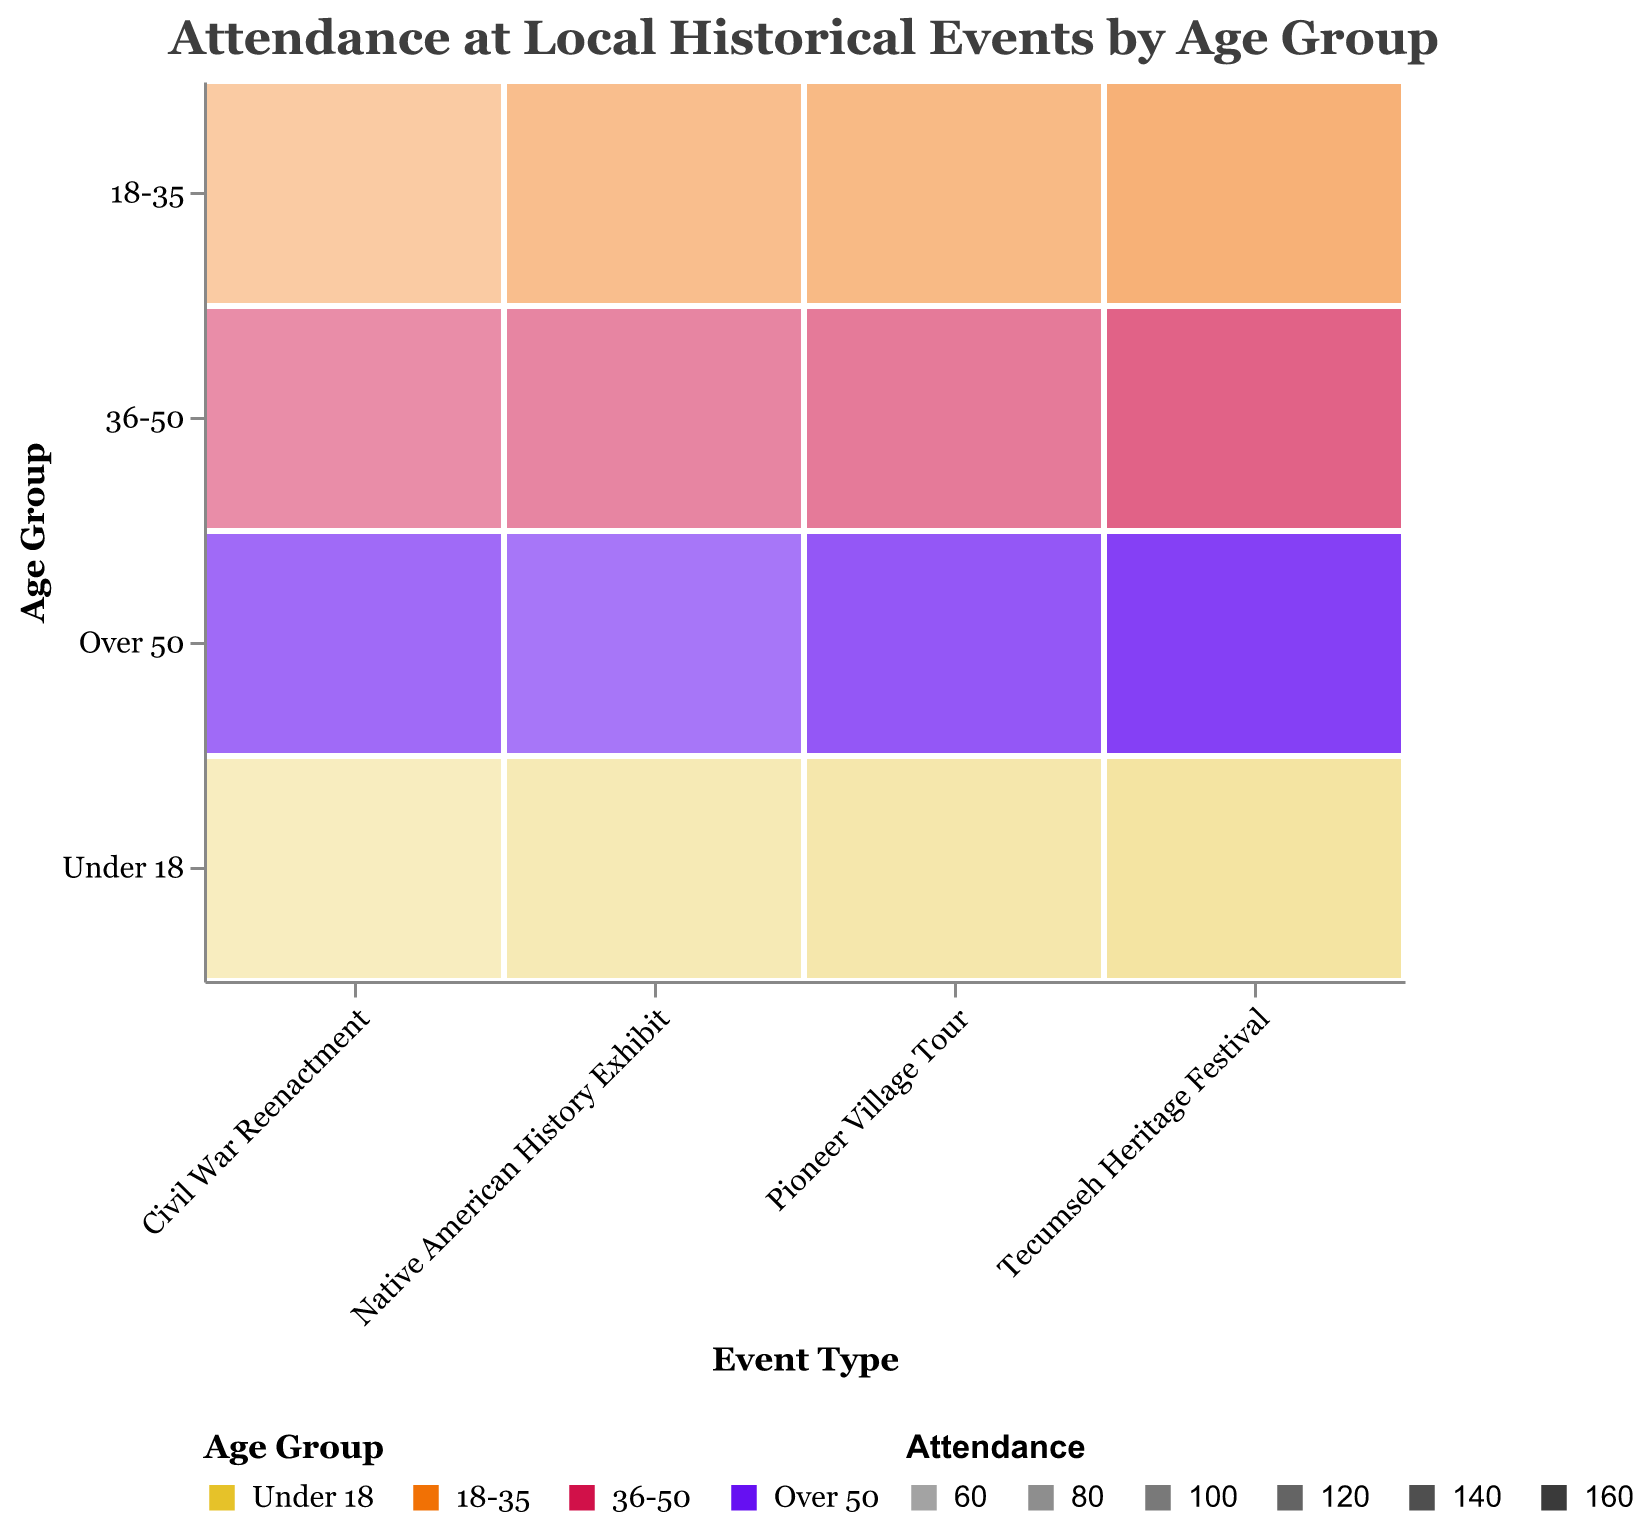What is the title of the figure? The title of the figure is displayed at the top and provides information about what the figure represents. In this case, it is about attendance rates at local historical events by different age groups.
Answer: Attendance at Local Historical Events by Age Group Which age group has the highest attendance for the Civil War Reenactment? By looking at the intensity of the color (opacity) for each age group in the Civil War Reenactment column, we can see that the "Over 50" age group has the darkest shade, indicating the highest attendance.
Answer: Over 50 What event type has the highest attendance for the 18-35 age group? By comparing the opacity of the color for the 18-35 age group across all event types, it is apparent that the Tecumseh Heritage Festival has the darkest shade, representing the highest attendance for that age group.
Answer: Tecumseh Heritage Festival How does the attendance for the Pioneer Village Tour compare between the "Under 18" and "Over 50" age groups? The "Over 50" age group has a much darker shade, indicating significantly higher attendance compared to the "Under 18" age group, which has a lighter shade.
Answer: Higher for Over 50 Which age group has the lowest attendance for the Native American History Exhibit? By checking the colors representing the different age groups under the Native American History Exhibit column, the "Under 18" age group has the lightest shade, indicating the lowest attendance.
Answer: Under 18 Which event type shows a consistent increase in attendance across all age groups? By observing the color intensity from "Under 18" to "Over 50" for each event type, only the Tecumseh Heritage Festival shows a consistent increase in darkness, representing increasing attendance across all age groups.
Answer: Tecumseh Heritage Festival What's the difference in attendance between the "Under 18" and "Over 50" age groups for the Civil War Reenactment? The "Under 18" group has 45 attendees, and the "Over 50" group has 124 attendees. The difference is 124 - 45 = 79.
Answer: 79 What is the average attendance for the 36-50 age group across all events? Sum the attendances of the 36-50 age group for each event type: 89 (Civil War Reenactment) + 133 (Tecumseh Heritage Festival) + 97 (Native American History Exhibit) + 108 (Pioneer Village Tour) = 427. Then divide by the number of events (4), so 427 / 4 = 106.75.
Answer: 106.75 For the Civil War Reenactment, which age group has the second highest attendance? The order of attendance from highest to lowest for the Civil War Reenactment is: Over 50 (124), 36-50 (89), 18-35 (62), Under 18 (45). The second highest is therefore the 36-50 age group.
Answer: 36-50 Is there any event where the attendance for the "Under 18" age group surpasses that of the "18-35" age group? By comparing the opacity for the "Under 18" and "18-35" age groups for each event type, there is no event where the attendance for the "Under 18" age group is greater than that of the "18-35" age group.
Answer: No 